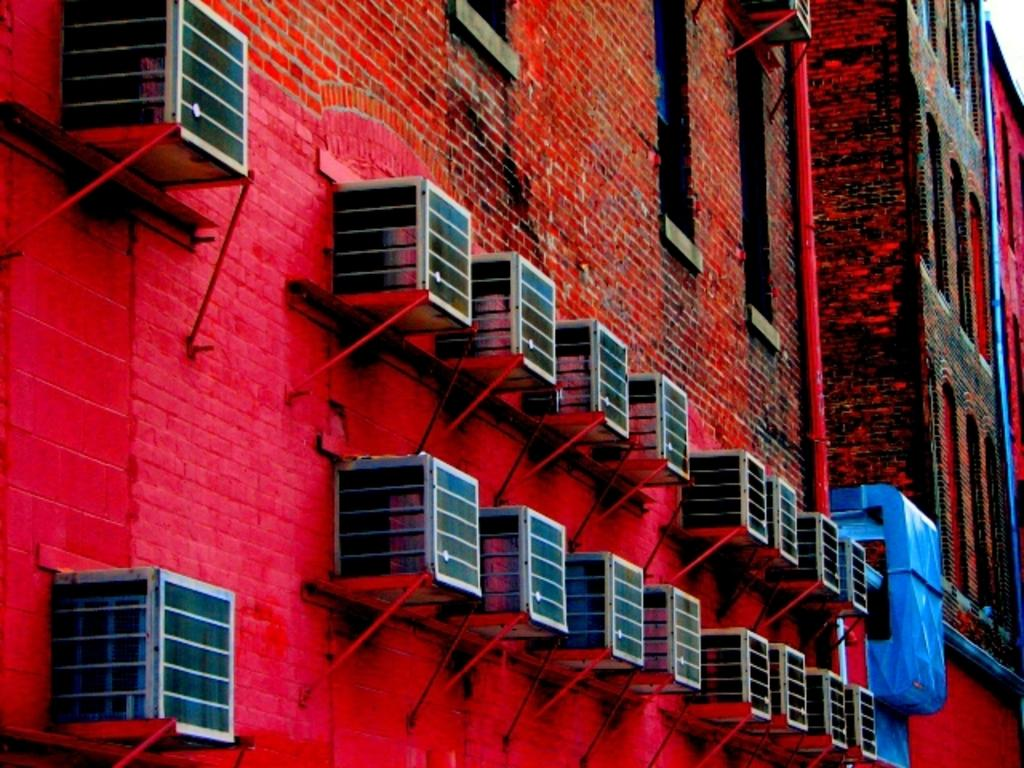What is the main subject of the image? The main subject of the image is the buildings in the center. What can be seen attached to the walls of the buildings? Condensers are attached to the walls of the buildings. How many slaves are visible in the image? There are no slaves present in the image. What type of authority figure can be seen in the image? There is no authority figure present in the image. 